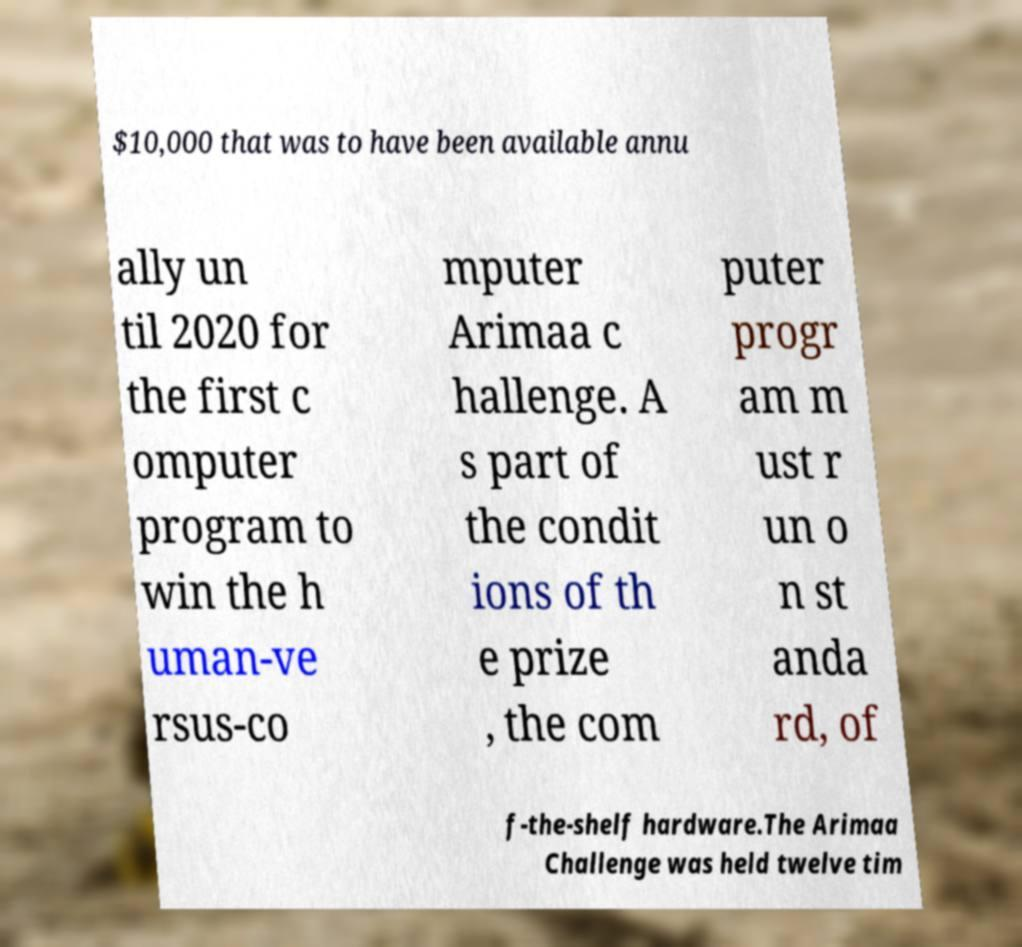Please identify and transcribe the text found in this image. $10,000 that was to have been available annu ally un til 2020 for the first c omputer program to win the h uman-ve rsus-co mputer Arimaa c hallenge. A s part of the condit ions of th e prize , the com puter progr am m ust r un o n st anda rd, of f-the-shelf hardware.The Arimaa Challenge was held twelve tim 